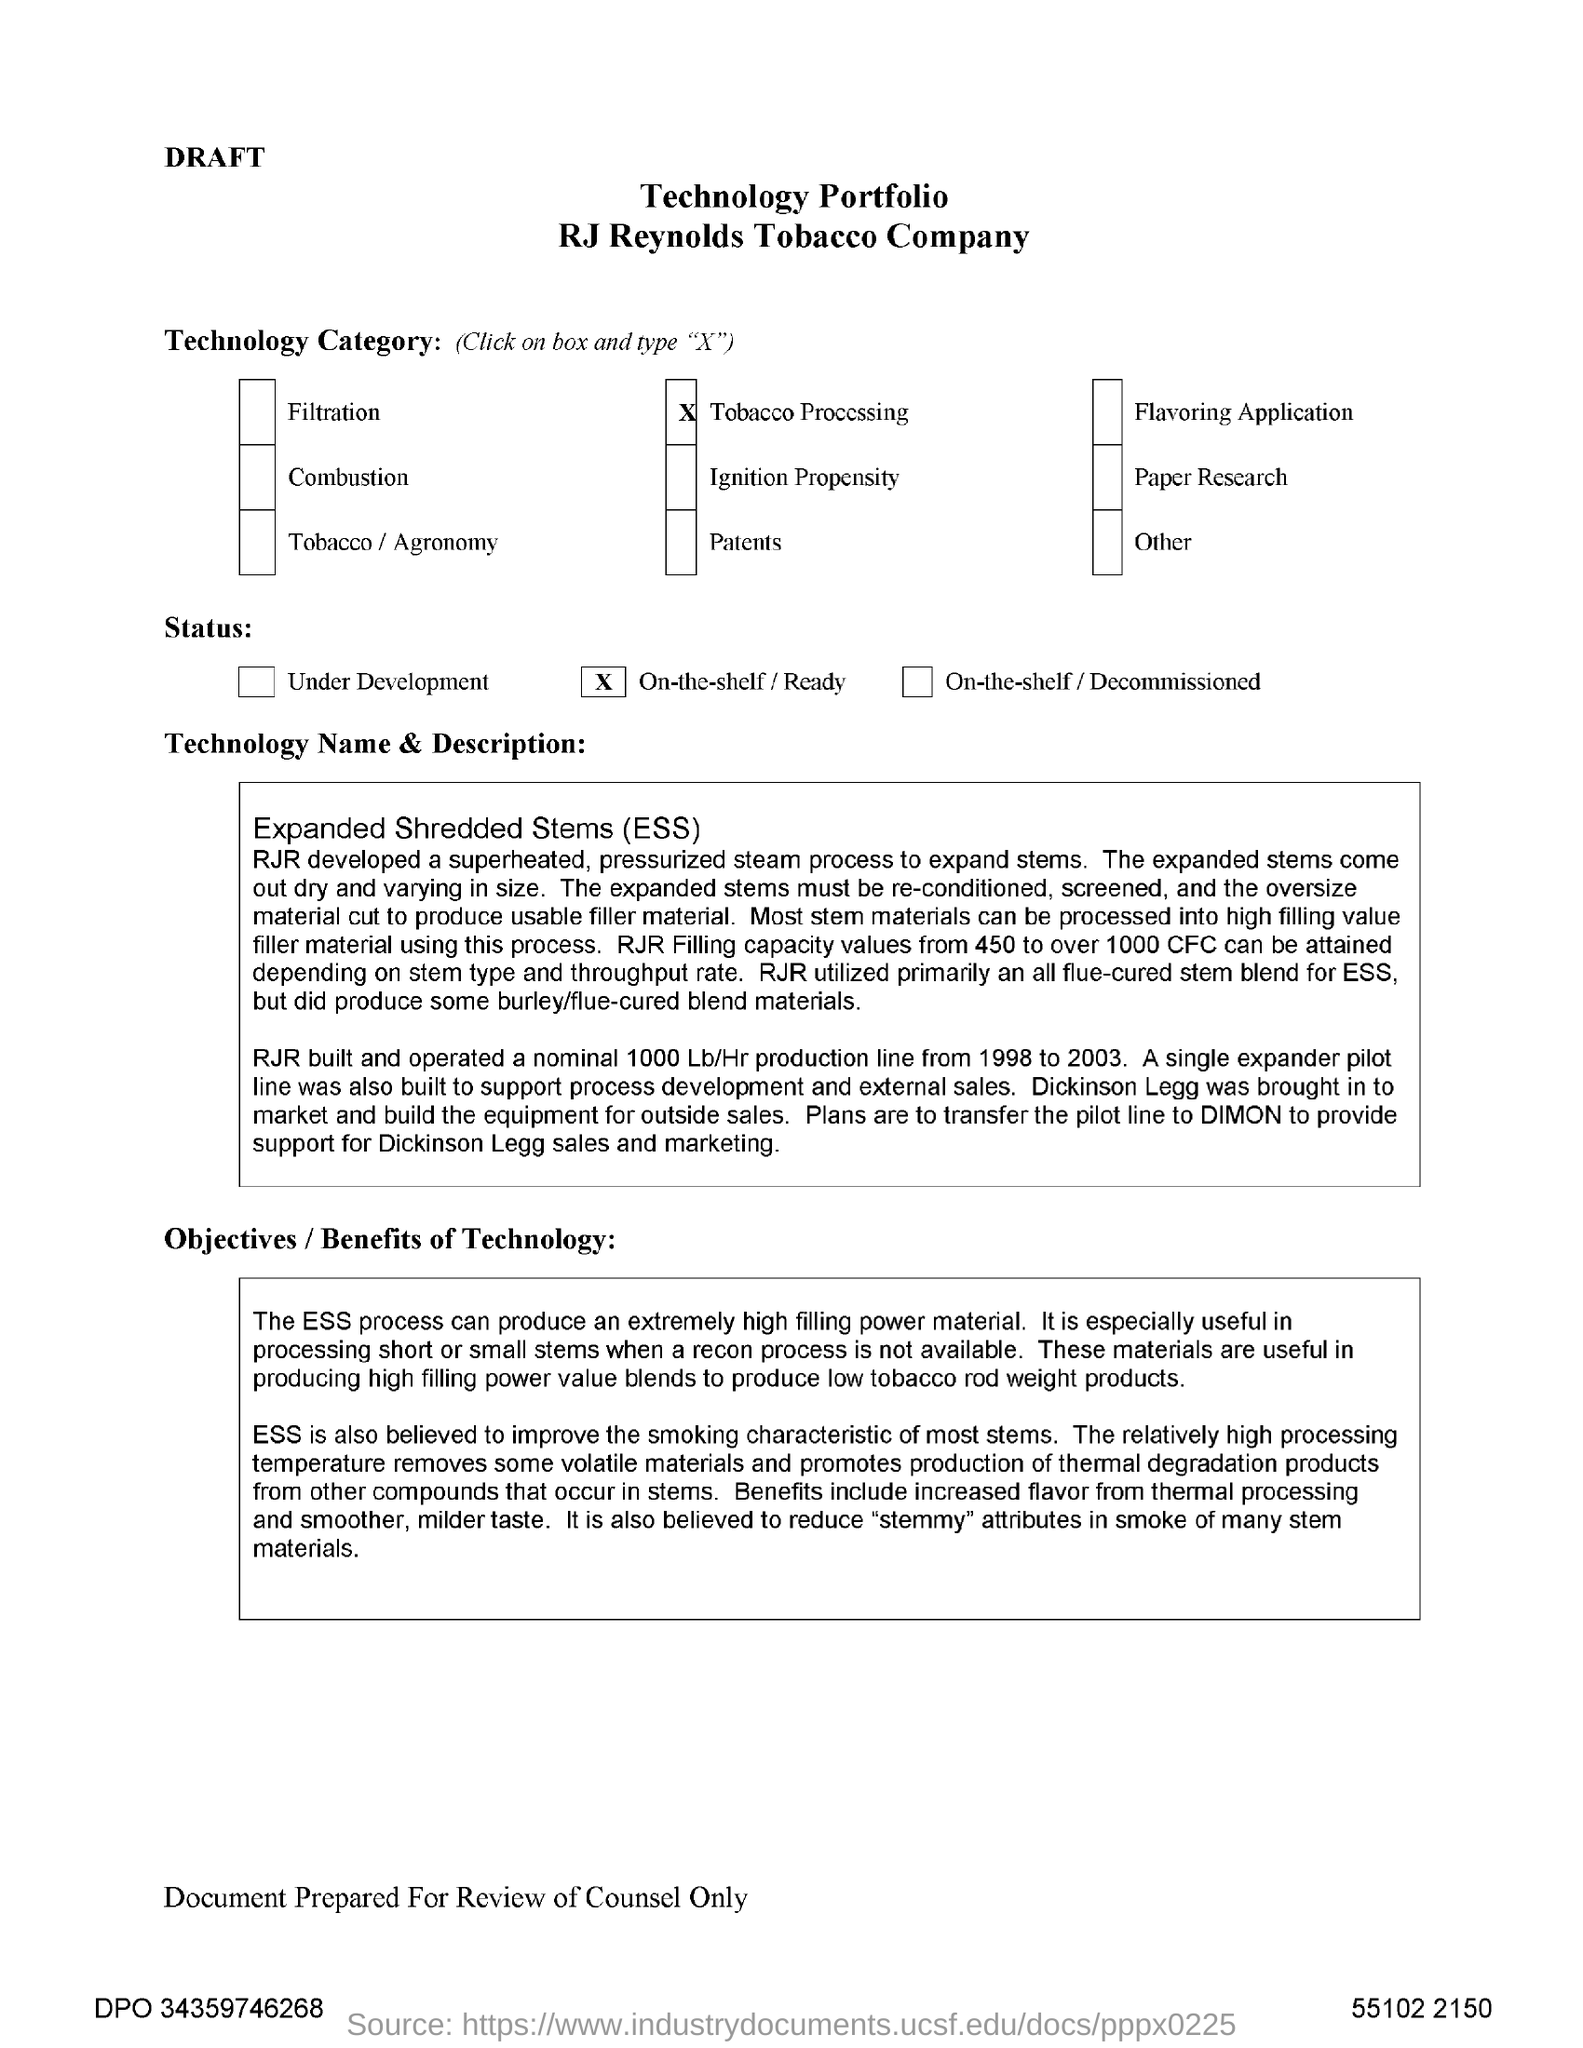Indicate a few pertinent items in this graphic. The range of RJR Filling capacity that can be attained in the ESS process depends on the stem type and throughput rate. It is possible to achieve a capacity of 450 to over 1000 CFC. Expanded Shredded Stems, commonly referred to as ESS, is a method of recycling and repurposing industrial waste by shredding and expanding it into usable materials. The technology category selected is tobacco processing. 